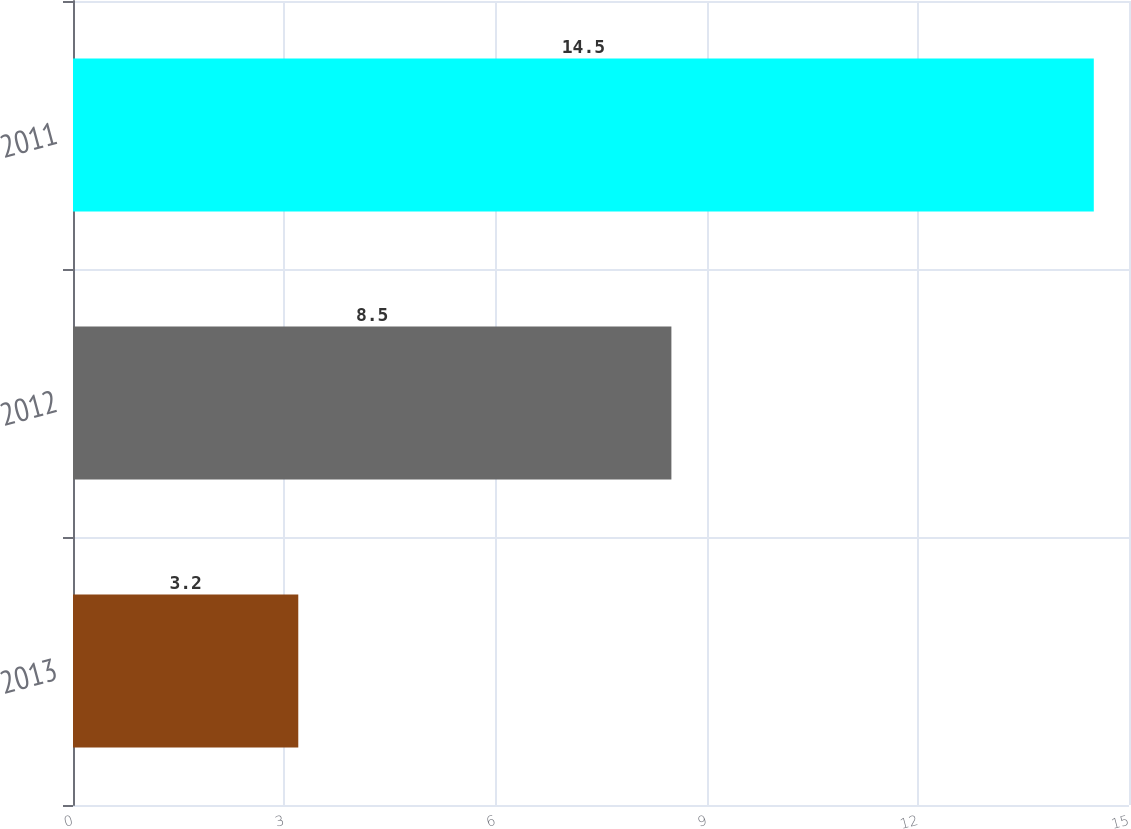Convert chart. <chart><loc_0><loc_0><loc_500><loc_500><bar_chart><fcel>2013<fcel>2012<fcel>2011<nl><fcel>3.2<fcel>8.5<fcel>14.5<nl></chart> 